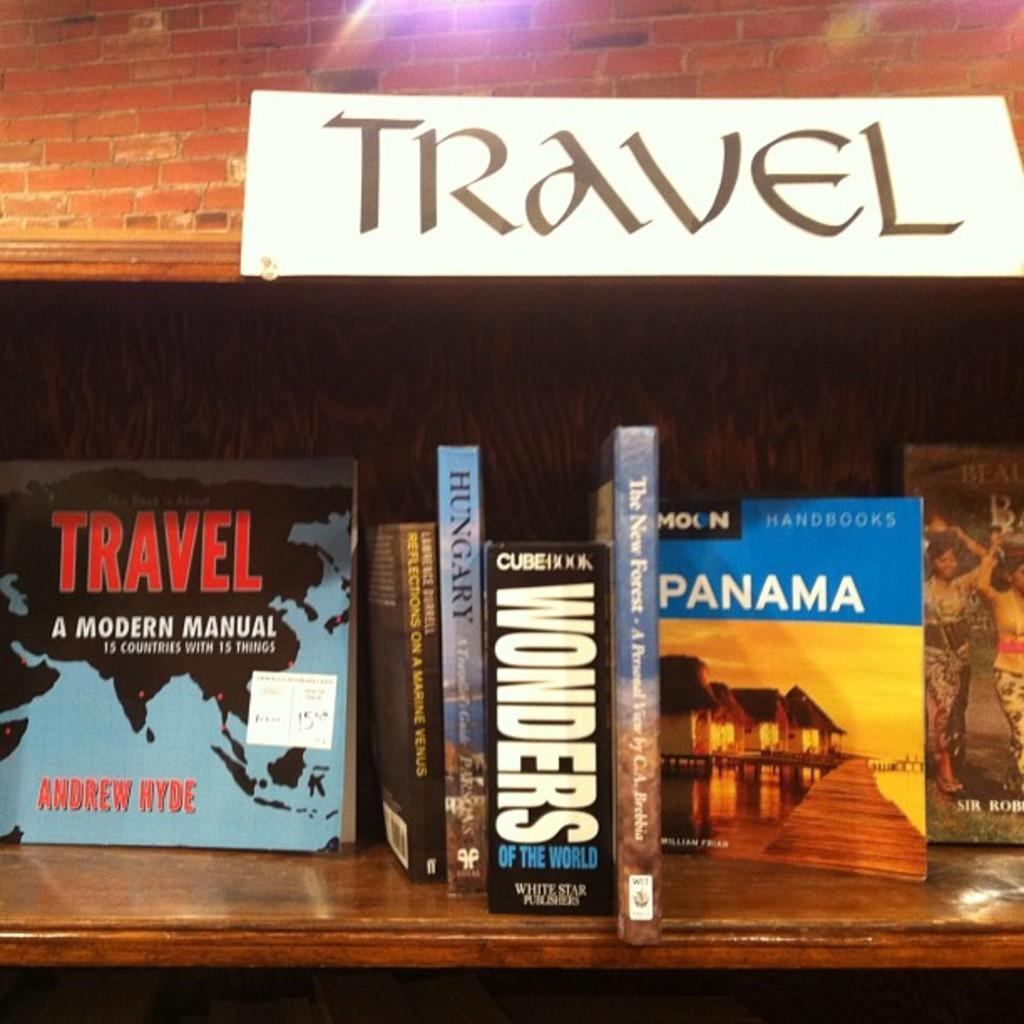<image>
Render a clear and concise summary of the photo. A line of books on a shelf labeled as "Travel". 